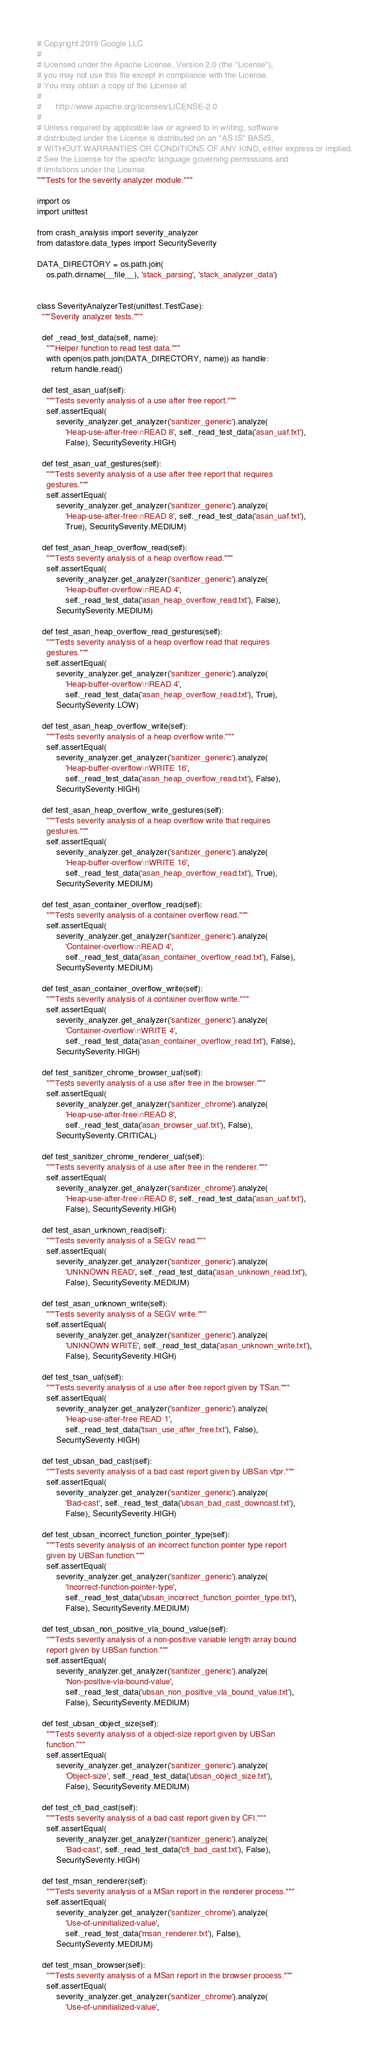Convert code to text. <code><loc_0><loc_0><loc_500><loc_500><_Python_># Copyright 2019 Google LLC
#
# Licensed under the Apache License, Version 2.0 (the "License");
# you may not use this file except in compliance with the License.
# You may obtain a copy of the License at
#
#      http://www.apache.org/licenses/LICENSE-2.0
#
# Unless required by applicable law or agreed to in writing, software
# distributed under the License is distributed on an "AS IS" BASIS,
# WITHOUT WARRANTIES OR CONDITIONS OF ANY KIND, either express or implied.
# See the License for the specific language governing permissions and
# limitations under the License.
"""Tests for the severity analyzer module."""

import os
import unittest

from crash_analysis import severity_analyzer
from datastore.data_types import SecuritySeverity

DATA_DIRECTORY = os.path.join(
    os.path.dirname(__file__), 'stack_parsing', 'stack_analyzer_data')


class SeverityAnalyzerTest(unittest.TestCase):
  """Severity analyzer tests."""

  def _read_test_data(self, name):
    """Helper function to read test data."""
    with open(os.path.join(DATA_DIRECTORY, name)) as handle:
      return handle.read()

  def test_asan_uaf(self):
    """Tests severity analysis of a use after free report."""
    self.assertEqual(
        severity_analyzer.get_analyzer('sanitizer_generic').analyze(
            'Heap-use-after-free\nREAD 8', self._read_test_data('asan_uaf.txt'),
            False), SecuritySeverity.HIGH)

  def test_asan_uaf_gestures(self):
    """Tests severity analysis of a use after free report that requires
    gestures."""
    self.assertEqual(
        severity_analyzer.get_analyzer('sanitizer_generic').analyze(
            'Heap-use-after-free\nREAD 8', self._read_test_data('asan_uaf.txt'),
            True), SecuritySeverity.MEDIUM)

  def test_asan_heap_overflow_read(self):
    """Tests severity analysis of a heap overflow read."""
    self.assertEqual(
        severity_analyzer.get_analyzer('sanitizer_generic').analyze(
            'Heap-buffer-overflow\nREAD 4',
            self._read_test_data('asan_heap_overflow_read.txt'), False),
        SecuritySeverity.MEDIUM)

  def test_asan_heap_overflow_read_gestures(self):
    """Tests severity analysis of a heap overflow read that requires
    gestures."""
    self.assertEqual(
        severity_analyzer.get_analyzer('sanitizer_generic').analyze(
            'Heap-buffer-overflow\nREAD 4',
            self._read_test_data('asan_heap_overflow_read.txt'), True),
        SecuritySeverity.LOW)

  def test_asan_heap_overflow_write(self):
    """Tests severity analysis of a heap overflow write."""
    self.assertEqual(
        severity_analyzer.get_analyzer('sanitizer_generic').analyze(
            'Heap-buffer-overflow\nWRITE 16',
            self._read_test_data('asan_heap_overflow_read.txt'), False),
        SecuritySeverity.HIGH)

  def test_asan_heap_overflow_write_gestures(self):
    """Tests severity analysis of a heap overflow write that requires
    gestures."""
    self.assertEqual(
        severity_analyzer.get_analyzer('sanitizer_generic').analyze(
            'Heap-buffer-overflow\nWRITE 16',
            self._read_test_data('asan_heap_overflow_read.txt'), True),
        SecuritySeverity.MEDIUM)

  def test_asan_container_overflow_read(self):
    """Tests severity analysis of a container overflow read."""
    self.assertEqual(
        severity_analyzer.get_analyzer('sanitizer_generic').analyze(
            'Container-overflow\nREAD 4',
            self._read_test_data('asan_container_overflow_read.txt'), False),
        SecuritySeverity.MEDIUM)

  def test_asan_container_overflow_write(self):
    """Tests severity analysis of a container overflow write."""
    self.assertEqual(
        severity_analyzer.get_analyzer('sanitizer_generic').analyze(
            'Container-overflow\nWRITE 4',
            self._read_test_data('asan_container_overflow_read.txt'), False),
        SecuritySeverity.HIGH)

  def test_sanitizer_chrome_browser_uaf(self):
    """Tests severity analysis of a use after free in the browser."""
    self.assertEqual(
        severity_analyzer.get_analyzer('sanitizer_chrome').analyze(
            'Heap-use-after-free\nREAD 8',
            self._read_test_data('asan_browser_uaf.txt'), False),
        SecuritySeverity.CRITICAL)

  def test_sanitizer_chrome_renderer_uaf(self):
    """Tests severity analysis of a use after free in the renderer."""
    self.assertEqual(
        severity_analyzer.get_analyzer('sanitizer_chrome').analyze(
            'Heap-use-after-free\nREAD 8', self._read_test_data('asan_uaf.txt'),
            False), SecuritySeverity.HIGH)

  def test_asan_unknown_read(self):
    """Tests severity analysis of a SEGV read."""
    self.assertEqual(
        severity_analyzer.get_analyzer('sanitizer_generic').analyze(
            'UNKNOWN READ', self._read_test_data('asan_unknown_read.txt'),
            False), SecuritySeverity.MEDIUM)

  def test_asan_unknown_write(self):
    """Tests severity analysis of a SEGV write."""
    self.assertEqual(
        severity_analyzer.get_analyzer('sanitizer_generic').analyze(
            'UNKNOWN WRITE', self._read_test_data('asan_unknown_write.txt'),
            False), SecuritySeverity.HIGH)

  def test_tsan_uaf(self):
    """Tests severity analysis of a use after free report given by TSan."""
    self.assertEqual(
        severity_analyzer.get_analyzer('sanitizer_generic').analyze(
            'Heap-use-after-free READ 1',
            self._read_test_data('tsan_use_after_free.txt'), False),
        SecuritySeverity.HIGH)

  def test_ubsan_bad_cast(self):
    """Tests severity analysis of a bad cast report given by UBSan vtpr."""
    self.assertEqual(
        severity_analyzer.get_analyzer('sanitizer_generic').analyze(
            'Bad-cast', self._read_test_data('ubsan_bad_cast_downcast.txt'),
            False), SecuritySeverity.HIGH)

  def test_ubsan_incorrect_function_pointer_type(self):
    """Tests severity analysis of an incorrect function pointer type report
    given by UBSan function."""
    self.assertEqual(
        severity_analyzer.get_analyzer('sanitizer_generic').analyze(
            'Incorrect-function-pointer-type',
            self._read_test_data('ubsan_incorrect_function_pointer_type.txt'),
            False), SecuritySeverity.MEDIUM)

  def test_ubsan_non_positive_vla_bound_value(self):
    """Tests severity analysis of a non-positive variable length array bound
    report given by UBSan function."""
    self.assertEqual(
        severity_analyzer.get_analyzer('sanitizer_generic').analyze(
            'Non-positive-vla-bound-value',
            self._read_test_data('ubsan_non_positive_vla_bound_value.txt'),
            False), SecuritySeverity.MEDIUM)

  def test_ubsan_object_size(self):
    """Tests severity analysis of a object-size report given by UBSan
    function."""
    self.assertEqual(
        severity_analyzer.get_analyzer('sanitizer_generic').analyze(
            'Object-size', self._read_test_data('ubsan_object_size.txt'),
            False), SecuritySeverity.MEDIUM)

  def test_cfi_bad_cast(self):
    """Tests severity analysis of a bad cast report given by CFI."""
    self.assertEqual(
        severity_analyzer.get_analyzer('sanitizer_generic').analyze(
            'Bad-cast', self._read_test_data('cfi_bad_cast.txt'), False),
        SecuritySeverity.HIGH)

  def test_msan_renderer(self):
    """Tests severity analysis of a MSan report in the renderer process."""
    self.assertEqual(
        severity_analyzer.get_analyzer('sanitizer_chrome').analyze(
            'Use-of-uninitialized-value',
            self._read_test_data('msan_renderer.txt'), False),
        SecuritySeverity.MEDIUM)

  def test_msan_browser(self):
    """Tests severity analysis of a MSan report in the browser process."""
    self.assertEqual(
        severity_analyzer.get_analyzer('sanitizer_chrome').analyze(
            'Use-of-uninitialized-value',</code> 